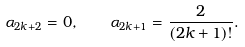Convert formula to latex. <formula><loc_0><loc_0><loc_500><loc_500>\alpha _ { 2 k + 2 } = 0 , \quad \alpha _ { 2 k + 1 } = \frac { 2 } { ( 2 k + 1 ) ! } .</formula> 